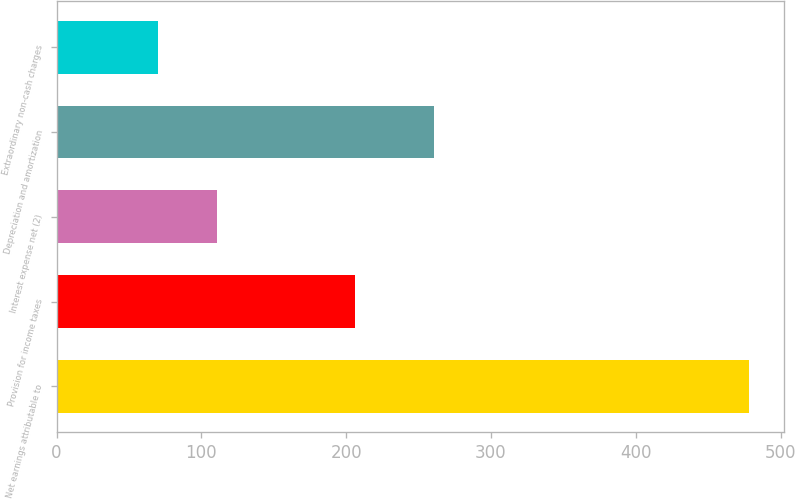Convert chart. <chart><loc_0><loc_0><loc_500><loc_500><bar_chart><fcel>Net earnings attributable to<fcel>Provision for income taxes<fcel>Interest expense net (2)<fcel>Depreciation and amortization<fcel>Extraordinary non-cash charges<nl><fcel>478.3<fcel>205.9<fcel>110.65<fcel>260.9<fcel>69.8<nl></chart> 